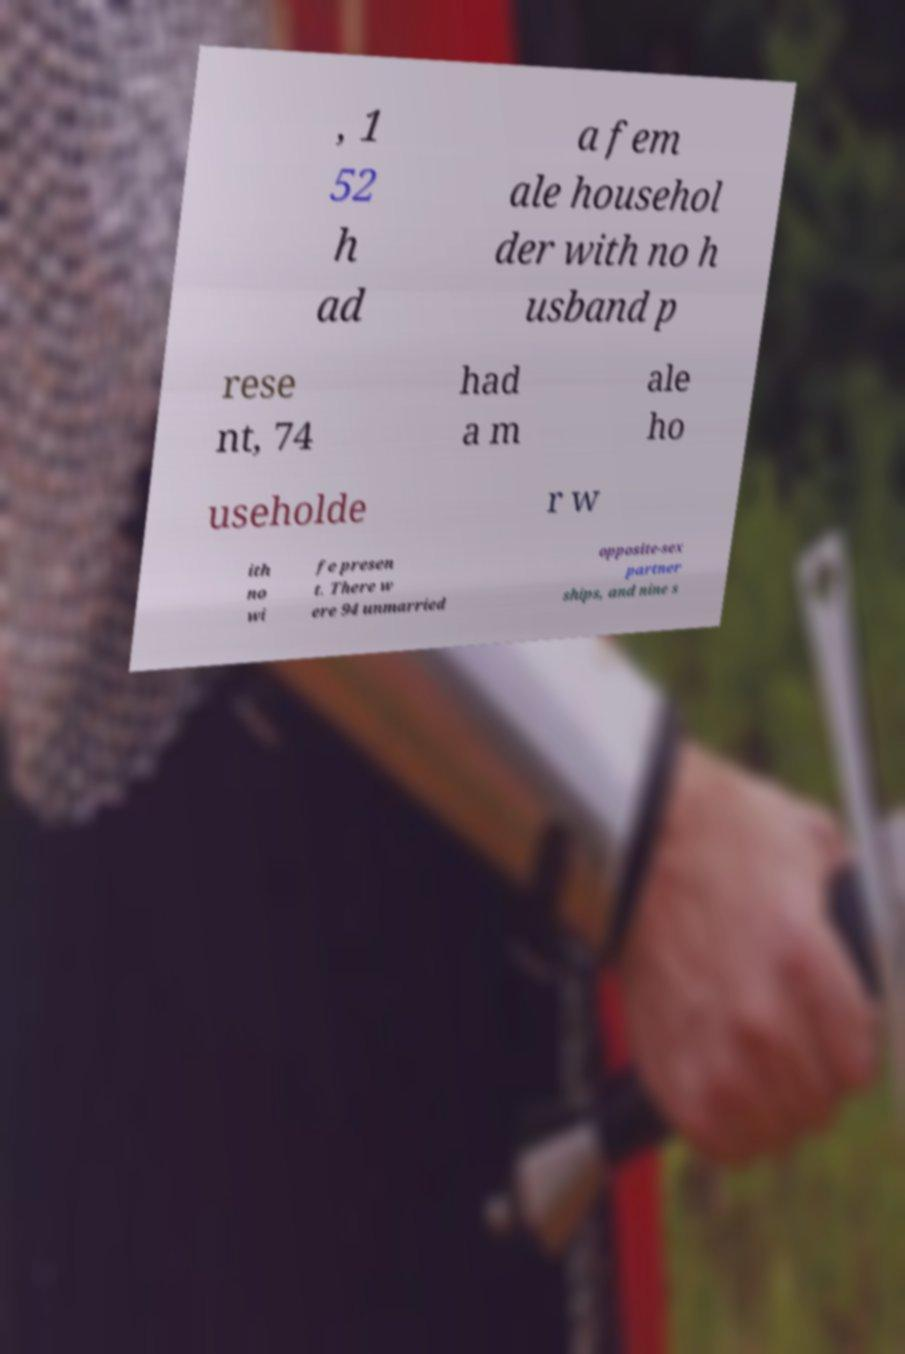Could you extract and type out the text from this image? , 1 52 h ad a fem ale househol der with no h usband p rese nt, 74 had a m ale ho useholde r w ith no wi fe presen t. There w ere 94 unmarried opposite-sex partner ships, and nine s 